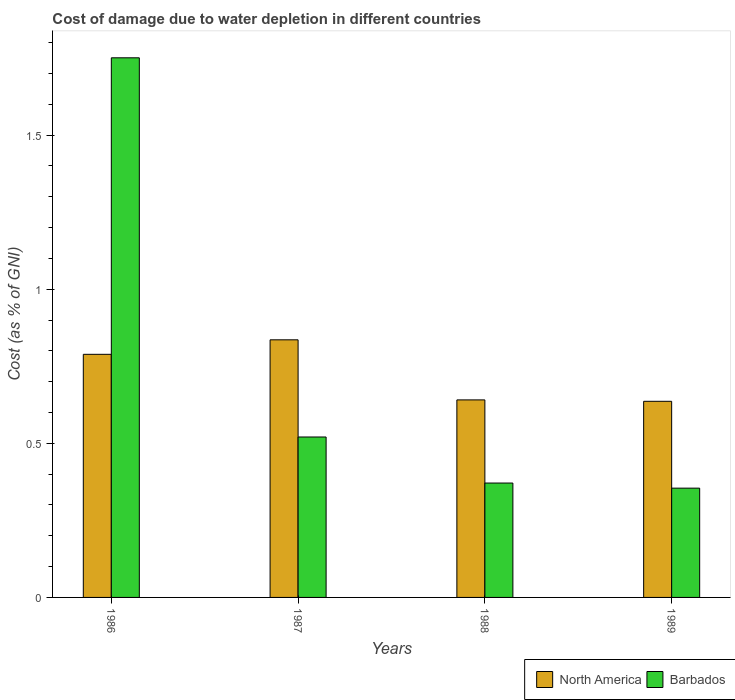Are the number of bars per tick equal to the number of legend labels?
Your answer should be compact. Yes. Are the number of bars on each tick of the X-axis equal?
Your response must be concise. Yes. What is the label of the 2nd group of bars from the left?
Offer a very short reply. 1987. What is the cost of damage caused due to water depletion in Barbados in 1989?
Offer a very short reply. 0.35. Across all years, what is the maximum cost of damage caused due to water depletion in Barbados?
Keep it short and to the point. 1.75. Across all years, what is the minimum cost of damage caused due to water depletion in North America?
Give a very brief answer. 0.64. In which year was the cost of damage caused due to water depletion in Barbados maximum?
Your answer should be very brief. 1986. What is the total cost of damage caused due to water depletion in North America in the graph?
Provide a succinct answer. 2.9. What is the difference between the cost of damage caused due to water depletion in North America in 1986 and that in 1989?
Make the answer very short. 0.15. What is the difference between the cost of damage caused due to water depletion in North America in 1987 and the cost of damage caused due to water depletion in Barbados in 1989?
Your answer should be compact. 0.48. What is the average cost of damage caused due to water depletion in North America per year?
Ensure brevity in your answer.  0.73. In the year 1986, what is the difference between the cost of damage caused due to water depletion in Barbados and cost of damage caused due to water depletion in North America?
Give a very brief answer. 0.96. In how many years, is the cost of damage caused due to water depletion in North America greater than 1.3 %?
Make the answer very short. 0. What is the ratio of the cost of damage caused due to water depletion in Barbados in 1988 to that in 1989?
Make the answer very short. 1.05. Is the cost of damage caused due to water depletion in North America in 1986 less than that in 1989?
Provide a succinct answer. No. What is the difference between the highest and the second highest cost of damage caused due to water depletion in North America?
Make the answer very short. 0.05. What is the difference between the highest and the lowest cost of damage caused due to water depletion in Barbados?
Make the answer very short. 1.4. In how many years, is the cost of damage caused due to water depletion in Barbados greater than the average cost of damage caused due to water depletion in Barbados taken over all years?
Ensure brevity in your answer.  1. Is the sum of the cost of damage caused due to water depletion in North America in 1986 and 1987 greater than the maximum cost of damage caused due to water depletion in Barbados across all years?
Make the answer very short. No. What does the 2nd bar from the left in 1989 represents?
Ensure brevity in your answer.  Barbados. Are all the bars in the graph horizontal?
Give a very brief answer. No. How many years are there in the graph?
Your response must be concise. 4. What is the difference between two consecutive major ticks on the Y-axis?
Provide a short and direct response. 0.5. Does the graph contain grids?
Provide a short and direct response. No. How many legend labels are there?
Provide a succinct answer. 2. What is the title of the graph?
Offer a terse response. Cost of damage due to water depletion in different countries. What is the label or title of the Y-axis?
Offer a very short reply. Cost (as % of GNI). What is the Cost (as % of GNI) of North America in 1986?
Make the answer very short. 0.79. What is the Cost (as % of GNI) in Barbados in 1986?
Provide a succinct answer. 1.75. What is the Cost (as % of GNI) of North America in 1987?
Your answer should be very brief. 0.84. What is the Cost (as % of GNI) in Barbados in 1987?
Keep it short and to the point. 0.52. What is the Cost (as % of GNI) in North America in 1988?
Ensure brevity in your answer.  0.64. What is the Cost (as % of GNI) of Barbados in 1988?
Provide a short and direct response. 0.37. What is the Cost (as % of GNI) of North America in 1989?
Your answer should be very brief. 0.64. What is the Cost (as % of GNI) of Barbados in 1989?
Your response must be concise. 0.35. Across all years, what is the maximum Cost (as % of GNI) of North America?
Your answer should be compact. 0.84. Across all years, what is the maximum Cost (as % of GNI) in Barbados?
Your answer should be compact. 1.75. Across all years, what is the minimum Cost (as % of GNI) in North America?
Your response must be concise. 0.64. Across all years, what is the minimum Cost (as % of GNI) of Barbados?
Ensure brevity in your answer.  0.35. What is the total Cost (as % of GNI) in North America in the graph?
Offer a very short reply. 2.9. What is the total Cost (as % of GNI) of Barbados in the graph?
Provide a short and direct response. 3. What is the difference between the Cost (as % of GNI) of North America in 1986 and that in 1987?
Your answer should be compact. -0.05. What is the difference between the Cost (as % of GNI) in Barbados in 1986 and that in 1987?
Make the answer very short. 1.23. What is the difference between the Cost (as % of GNI) of North America in 1986 and that in 1988?
Keep it short and to the point. 0.15. What is the difference between the Cost (as % of GNI) of Barbados in 1986 and that in 1988?
Provide a short and direct response. 1.38. What is the difference between the Cost (as % of GNI) of North America in 1986 and that in 1989?
Make the answer very short. 0.15. What is the difference between the Cost (as % of GNI) in Barbados in 1986 and that in 1989?
Keep it short and to the point. 1.4. What is the difference between the Cost (as % of GNI) in North America in 1987 and that in 1988?
Offer a terse response. 0.19. What is the difference between the Cost (as % of GNI) of Barbados in 1987 and that in 1988?
Make the answer very short. 0.15. What is the difference between the Cost (as % of GNI) of North America in 1987 and that in 1989?
Provide a short and direct response. 0.2. What is the difference between the Cost (as % of GNI) of Barbados in 1987 and that in 1989?
Offer a very short reply. 0.17. What is the difference between the Cost (as % of GNI) of North America in 1988 and that in 1989?
Provide a succinct answer. 0. What is the difference between the Cost (as % of GNI) of Barbados in 1988 and that in 1989?
Your answer should be compact. 0.02. What is the difference between the Cost (as % of GNI) of North America in 1986 and the Cost (as % of GNI) of Barbados in 1987?
Make the answer very short. 0.27. What is the difference between the Cost (as % of GNI) of North America in 1986 and the Cost (as % of GNI) of Barbados in 1988?
Offer a very short reply. 0.42. What is the difference between the Cost (as % of GNI) in North America in 1986 and the Cost (as % of GNI) in Barbados in 1989?
Ensure brevity in your answer.  0.43. What is the difference between the Cost (as % of GNI) in North America in 1987 and the Cost (as % of GNI) in Barbados in 1988?
Keep it short and to the point. 0.46. What is the difference between the Cost (as % of GNI) in North America in 1987 and the Cost (as % of GNI) in Barbados in 1989?
Give a very brief answer. 0.48. What is the difference between the Cost (as % of GNI) of North America in 1988 and the Cost (as % of GNI) of Barbados in 1989?
Ensure brevity in your answer.  0.29. What is the average Cost (as % of GNI) in North America per year?
Offer a terse response. 0.73. What is the average Cost (as % of GNI) of Barbados per year?
Provide a succinct answer. 0.75. In the year 1986, what is the difference between the Cost (as % of GNI) in North America and Cost (as % of GNI) in Barbados?
Offer a terse response. -0.96. In the year 1987, what is the difference between the Cost (as % of GNI) of North America and Cost (as % of GNI) of Barbados?
Give a very brief answer. 0.32. In the year 1988, what is the difference between the Cost (as % of GNI) in North America and Cost (as % of GNI) in Barbados?
Provide a succinct answer. 0.27. In the year 1989, what is the difference between the Cost (as % of GNI) of North America and Cost (as % of GNI) of Barbados?
Give a very brief answer. 0.28. What is the ratio of the Cost (as % of GNI) in North America in 1986 to that in 1987?
Your response must be concise. 0.94. What is the ratio of the Cost (as % of GNI) in Barbados in 1986 to that in 1987?
Your answer should be compact. 3.36. What is the ratio of the Cost (as % of GNI) in North America in 1986 to that in 1988?
Keep it short and to the point. 1.23. What is the ratio of the Cost (as % of GNI) of Barbados in 1986 to that in 1988?
Give a very brief answer. 4.72. What is the ratio of the Cost (as % of GNI) of North America in 1986 to that in 1989?
Your answer should be very brief. 1.24. What is the ratio of the Cost (as % of GNI) of Barbados in 1986 to that in 1989?
Your answer should be compact. 4.94. What is the ratio of the Cost (as % of GNI) in North America in 1987 to that in 1988?
Your response must be concise. 1.3. What is the ratio of the Cost (as % of GNI) of Barbados in 1987 to that in 1988?
Ensure brevity in your answer.  1.4. What is the ratio of the Cost (as % of GNI) of North America in 1987 to that in 1989?
Offer a very short reply. 1.31. What is the ratio of the Cost (as % of GNI) of Barbados in 1987 to that in 1989?
Keep it short and to the point. 1.47. What is the ratio of the Cost (as % of GNI) of North America in 1988 to that in 1989?
Provide a succinct answer. 1.01. What is the ratio of the Cost (as % of GNI) in Barbados in 1988 to that in 1989?
Make the answer very short. 1.05. What is the difference between the highest and the second highest Cost (as % of GNI) in North America?
Give a very brief answer. 0.05. What is the difference between the highest and the second highest Cost (as % of GNI) of Barbados?
Your answer should be compact. 1.23. What is the difference between the highest and the lowest Cost (as % of GNI) in North America?
Make the answer very short. 0.2. What is the difference between the highest and the lowest Cost (as % of GNI) in Barbados?
Your answer should be very brief. 1.4. 